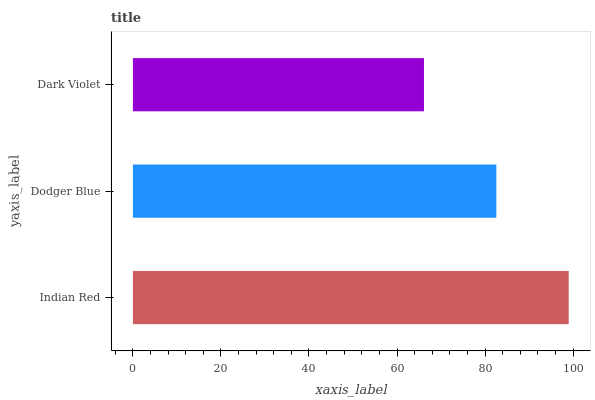Is Dark Violet the minimum?
Answer yes or no. Yes. Is Indian Red the maximum?
Answer yes or no. Yes. Is Dodger Blue the minimum?
Answer yes or no. No. Is Dodger Blue the maximum?
Answer yes or no. No. Is Indian Red greater than Dodger Blue?
Answer yes or no. Yes. Is Dodger Blue less than Indian Red?
Answer yes or no. Yes. Is Dodger Blue greater than Indian Red?
Answer yes or no. No. Is Indian Red less than Dodger Blue?
Answer yes or no. No. Is Dodger Blue the high median?
Answer yes or no. Yes. Is Dodger Blue the low median?
Answer yes or no. Yes. Is Dark Violet the high median?
Answer yes or no. No. Is Indian Red the low median?
Answer yes or no. No. 